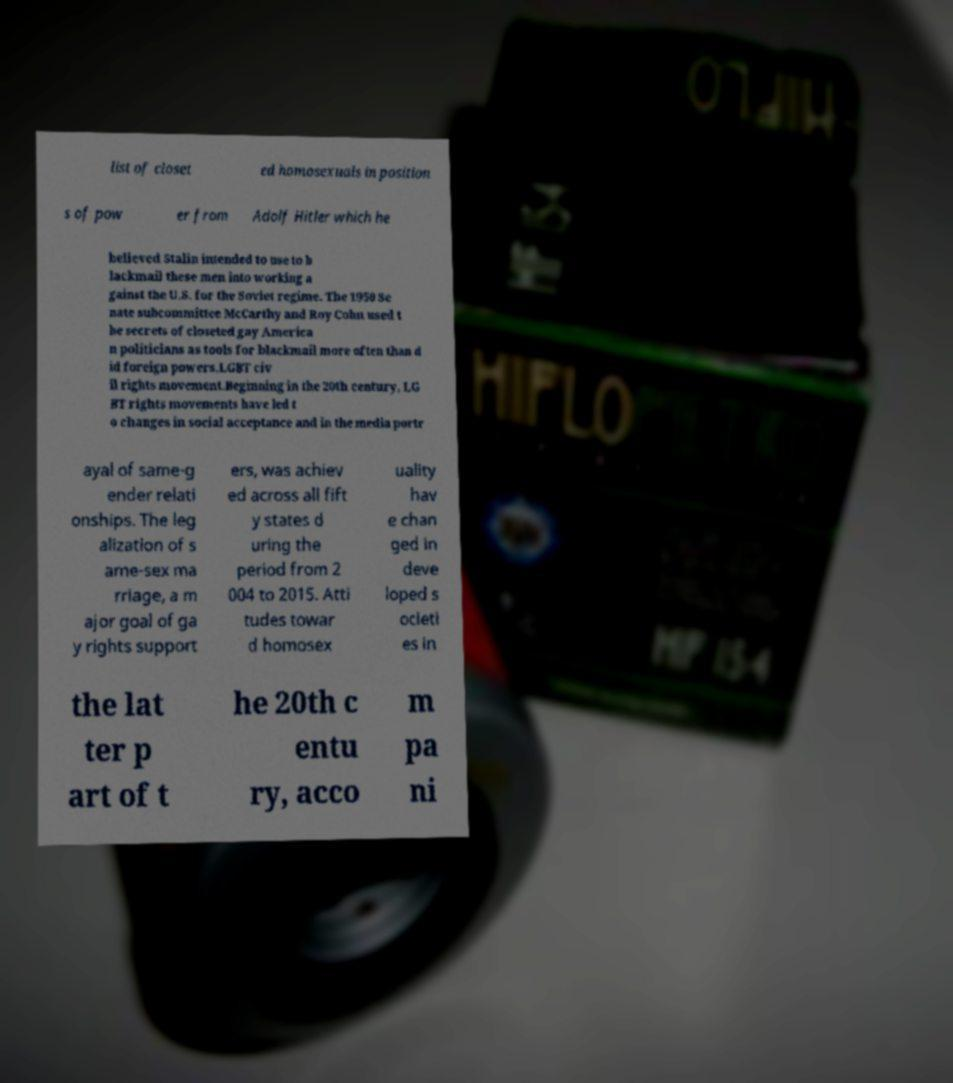Please read and relay the text visible in this image. What does it say? list of closet ed homosexuals in position s of pow er from Adolf Hitler which he believed Stalin intended to use to b lackmail these men into working a gainst the U.S. for the Soviet regime. The 1950 Se nate subcommittee McCarthy and Roy Cohn used t he secrets of closeted gay America n politicians as tools for blackmail more often than d id foreign powers.LGBT civ il rights movement.Beginning in the 20th century, LG BT rights movements have led t o changes in social acceptance and in the media portr ayal of same-g ender relati onships. The leg alization of s ame-sex ma rriage, a m ajor goal of ga y rights support ers, was achiev ed across all fift y states d uring the period from 2 004 to 2015. Atti tudes towar d homosex uality hav e chan ged in deve loped s ocieti es in the lat ter p art of t he 20th c entu ry, acco m pa ni 